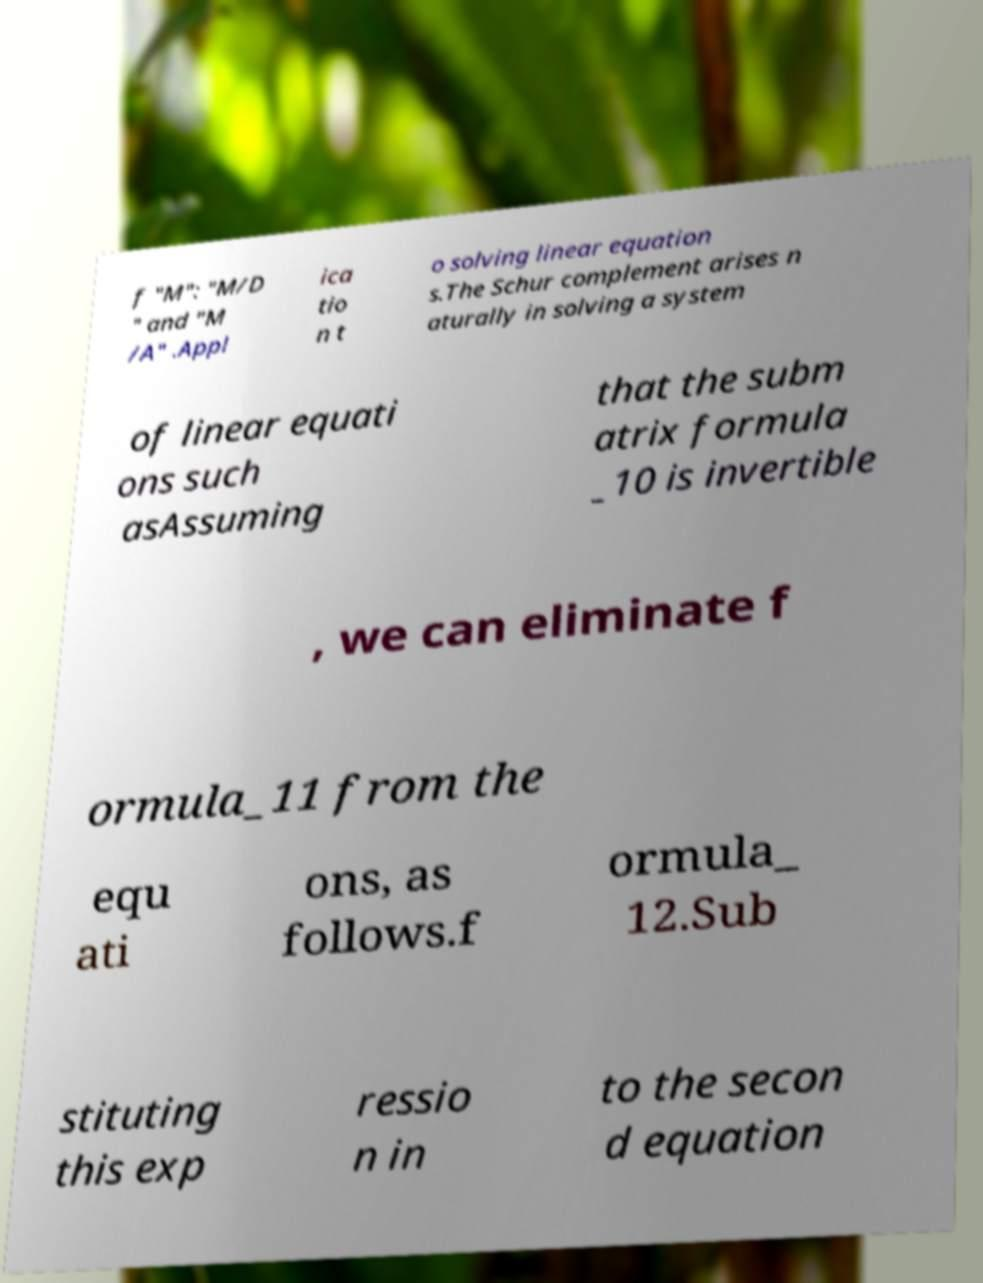Could you assist in decoding the text presented in this image and type it out clearly? f "M": "M/D " and "M /A" .Appl ica tio n t o solving linear equation s.The Schur complement arises n aturally in solving a system of linear equati ons such asAssuming that the subm atrix formula _10 is invertible , we can eliminate f ormula_11 from the equ ati ons, as follows.f ormula_ 12.Sub stituting this exp ressio n in to the secon d equation 